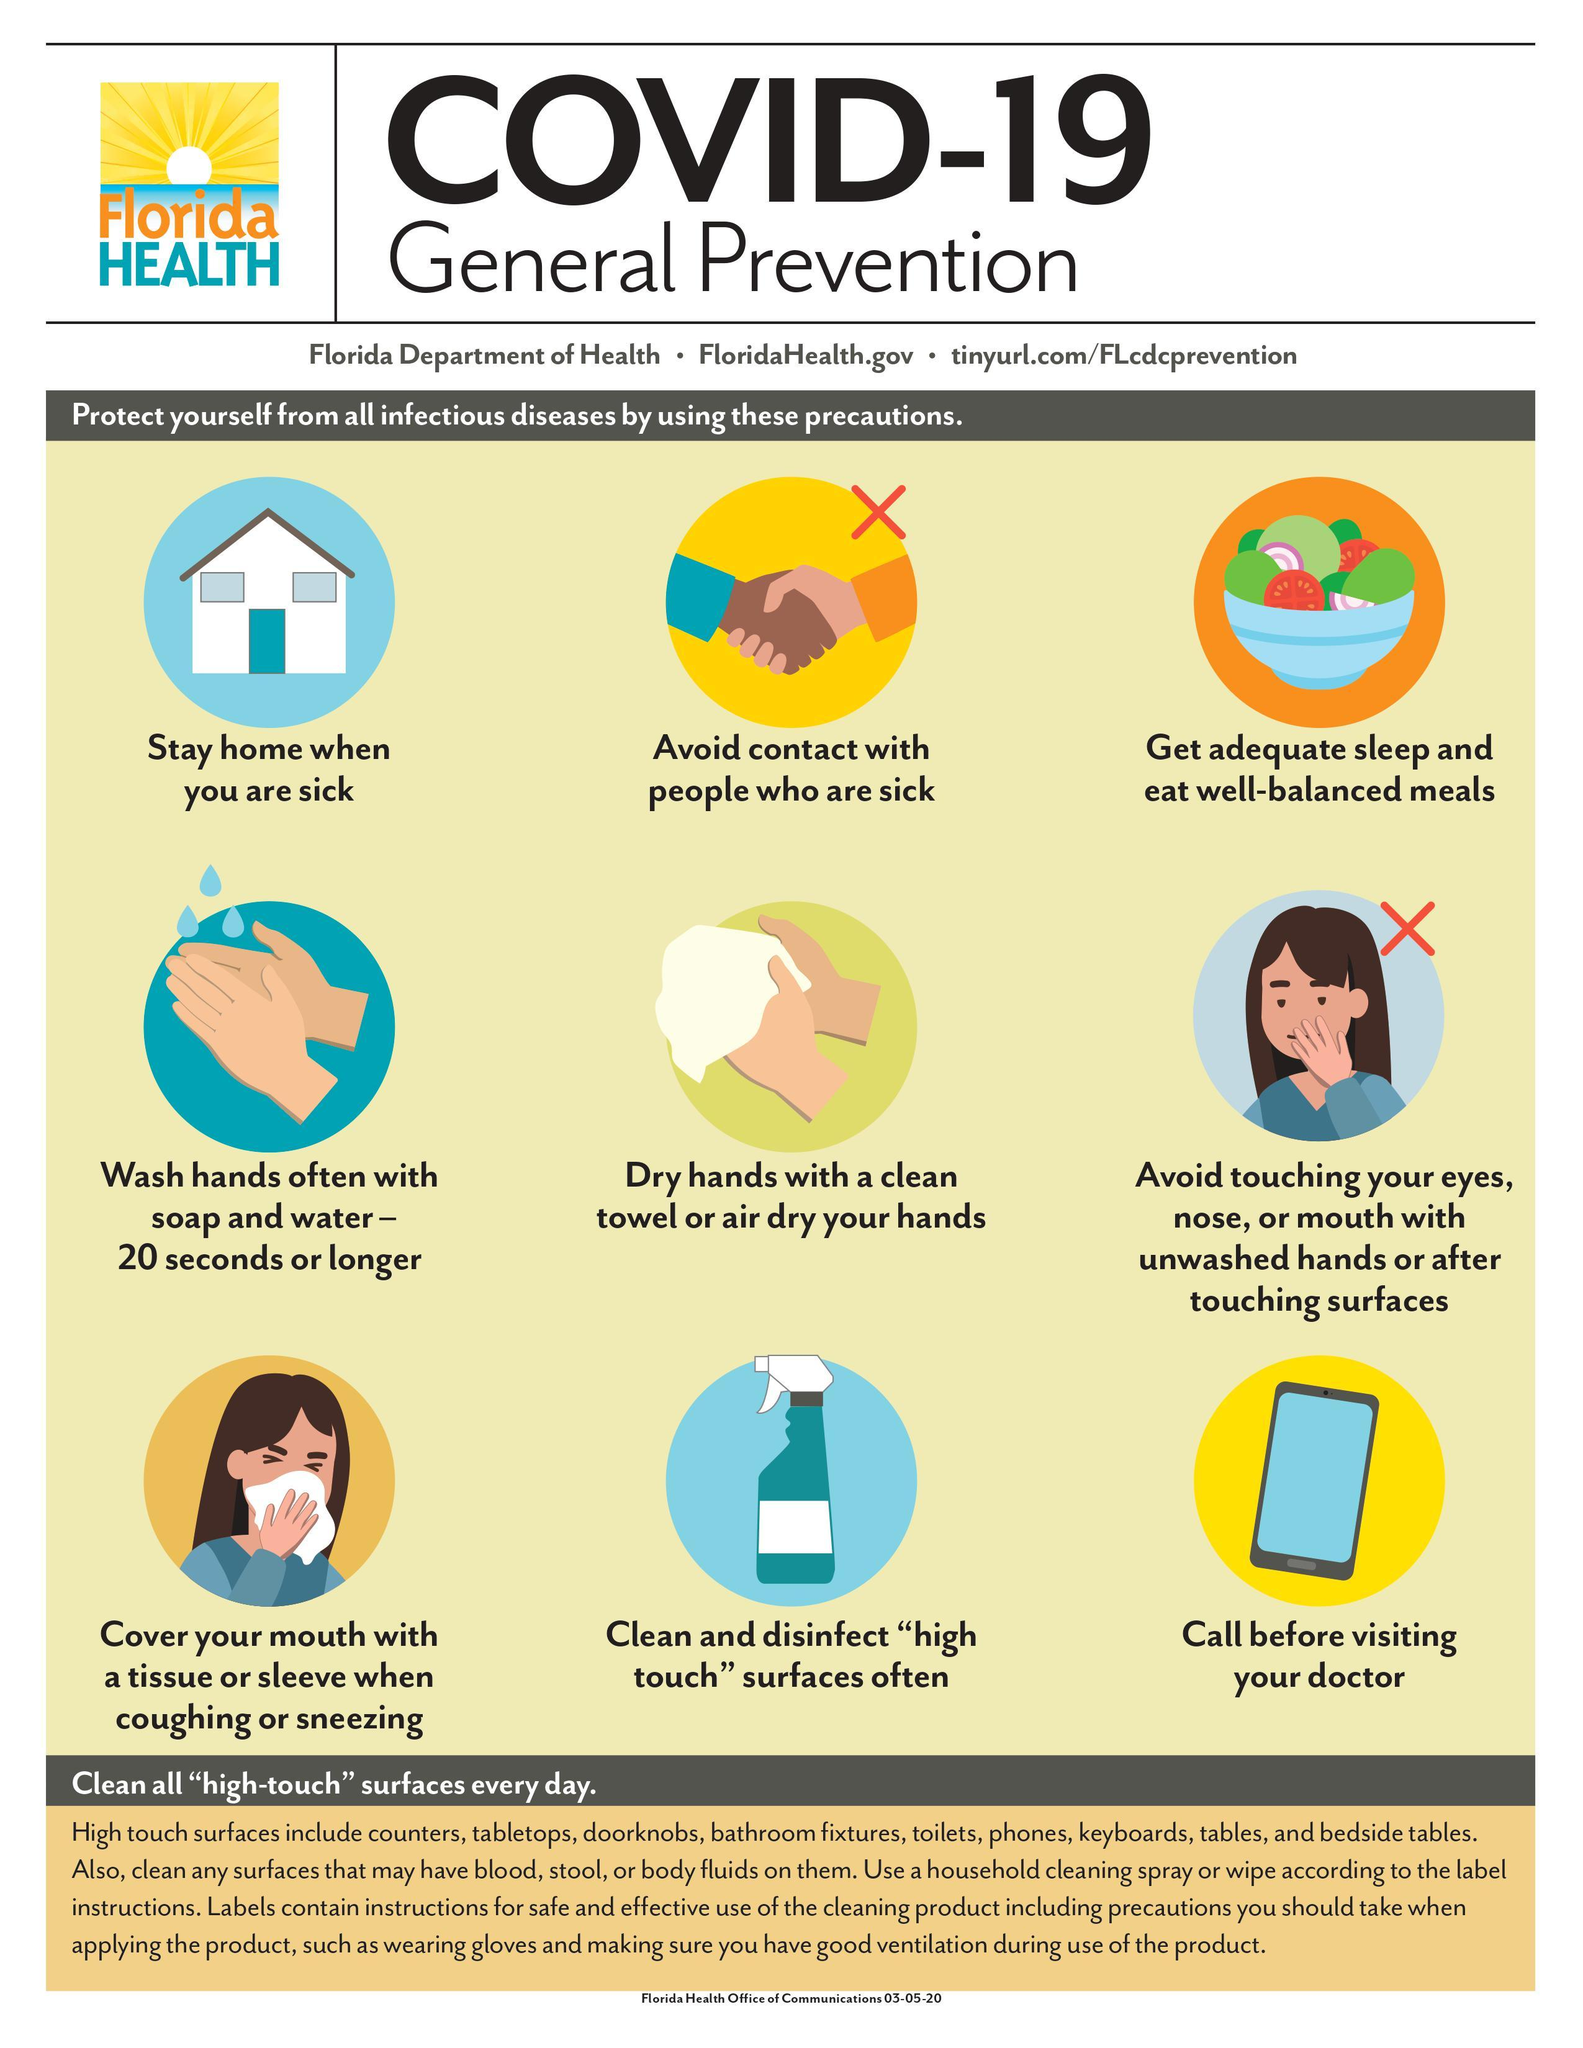Specify some key components in this picture. Of the precautions listed, two specifically mention actions that should not be taken. It is not advisable to touch the eyes, nose, and mouth with unclean hands as this can lead to the transmission of harmful bacteria and viruses. It is necessary to stay at home when one is sick. The image of a bowl of fruits and vegetables represents the precaution of getting adequate sleep and eating well-balanced meals, which is essential for maintaining good health and preventing illness. It is recommended to wash your hands for at least 20 seconds to ensure safety. 